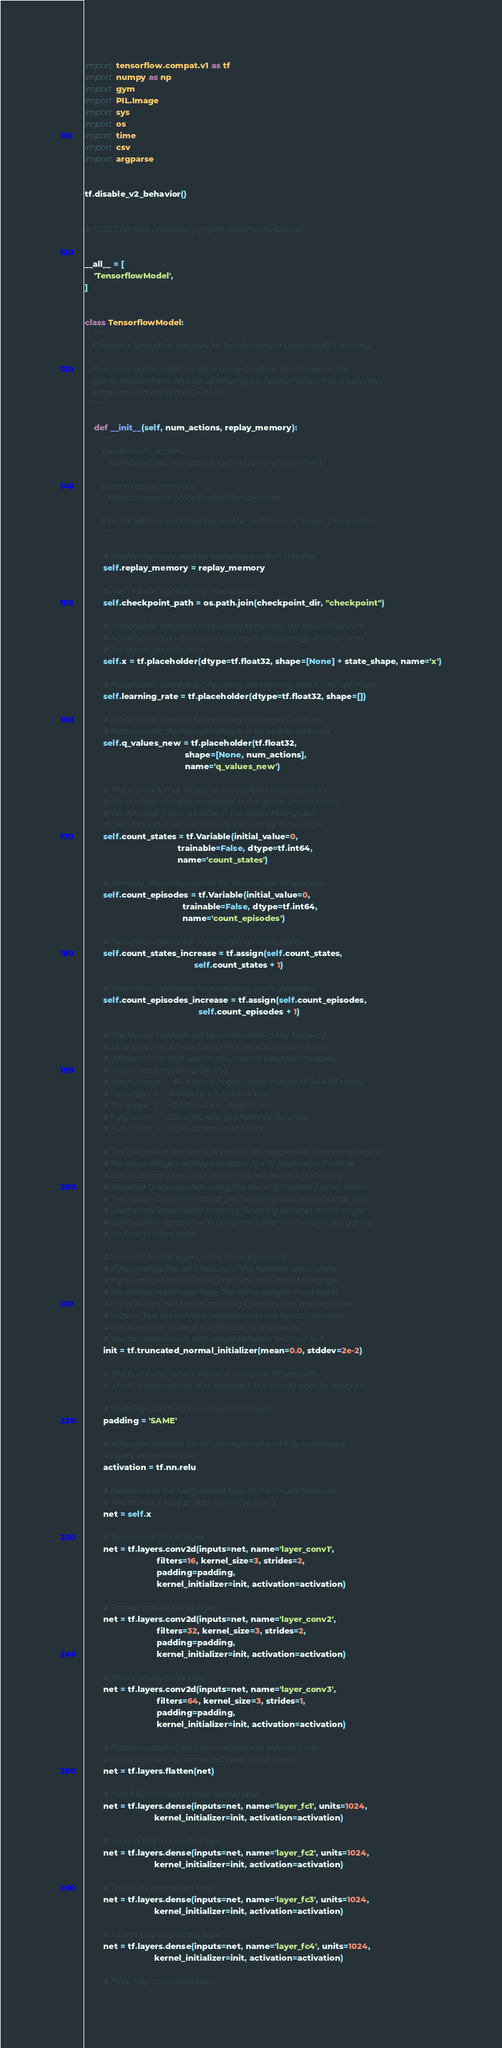<code> <loc_0><loc_0><loc_500><loc_500><_Python_>import tensorflow.compat.v1 as tf
import numpy as np
import gym
import PIL.Image
import sys
import os
import time
import csv
import argparse


tf.disable_v2_behavior()


# TODO: remove unecessary import statements (above).


__all__ = [
	'TensorflowModel',
]


class TensorflowModel:
	"""
	Creates a Tensorflow Network for Reinforcement Learning (Q-Learning).

	Functions are provided for estimating Q-values from states of the
	game-environment, and for optimizing the Neural Network so it becomes
	better at estimating the Q-values.
	"""

	def __init__(self, num_actions, replay_memory):
		"""
		:param num_actions:
			Number of discrete actions for the game-environment.

		:param replay_memory:
			Object-instance of the ReplayMemory-class.

		# HIGH: add network type parameter with choices: 'nupic' | 'tensorflow'
		"""

		# Replay-memory used for sampling random batches.
		self.replay_memory = replay_memory

		# Path for saving/restoring checkpoints.
		self.checkpoint_path = os.path.join(checkpoint_dir, "checkpoint")

		# Placeholder variable for inputting states into the Neural Network.
		# A state is a multi-dimensional array holding image-frames from
		# the game-environment.
		self.x = tf.placeholder(dtype=tf.float32, shape=[None] + state_shape, name='x')

		# Placeholder variable for inputting the learning-rate to the optimizer.
		self.learning_rate = tf.placeholder(dtype=tf.float32, shape=[])

		# Placeholder variable for inputting the target Q-values
		# that we want the Neural Network to be able to estimate.
		self.q_values_new = tf.placeholder(tf.float32,
										   shape=[None, num_actions],
										   name='q_values_new')

		# This is a hack that allows us to save/load the counter for
		# the number of states processed in the game-environment.
		# We will keep it as a variable in the TensorFlow-graph
		# even though it will not actually be used by TensorFlow.
		self.count_states = tf.Variable(initial_value=0,
										trainable=False, dtype=tf.int64,
										name='count_states')

		# Similarly, this is the counter for the number of episodes.
		self.count_episodes = tf.Variable(initial_value=0,
										  trainable=False, dtype=tf.int64,
										  name='count_episodes')

		# TensorFlow operation for increasing count_states.
		self.count_states_increase = tf.assign(self.count_states,
											   self.count_states + 1)

		# TensorFlow operation for increasing count_episodes.
		self.count_episodes_increase = tf.assign(self.count_episodes,
												 self.count_episodes + 1)

		# The Neural Network will be constructed in the following.
		# Note that the architecture of this Neural Network is very
		# different from that used in the original DeepMind papers,
		# which was something like this:
		# Input image:      84 x 84 x 4 (4 gray-scale images of 84 x 84 pixels).
		# Conv layer 1:     16 filters 8 x 8, stride 4, relu.
		# Conv layer 2:     32 filters 4 x 4, stride 2, relu.
		# Fully-conn. 1:    256 units, relu. (Sometimes 512 units).
		# Fully-conn. 2:    num-action units, linear.

		# The DeepMind architecture does a very aggressive downsampling of
		# the input images so they are about 10 x 10 pixels after the final
		# convolutional layer. I found that this resulted in significantly
		# distorted Q-values when using the training method further below.
		# The reason DeepMind could get it working was perhaps that they
		# used a very large replay memory (5x as big as here), and a single
		# optimization iteration was performed after each step of the game,
		# and some more tricks.

		# Initializer for the layers in the Neural Network.
		# If you change the architecture of the network, particularly
		# if you add or remove layers, then you may have to change
		# the stddev-parameter here. The initial weights must result
		# in the Neural Network outputting Q-values that are very close
		# to zero - but the network weights must not be too low either
		# because it will make it hard to train the network.
		# You can experiment with values between 1e-2 and 1e-3.
		init = tf.truncated_normal_initializer(mean=0.0, stddev=2e-2)

		# This builds the Neural Network using the tf.layers API,
		# which is very verbose and inelegant, but should work for everyone.

		# Padding used for the convolutional layers.
		padding = 'SAME'

		# Activation function for all convolutional and fully-connected
		# layers, except the last.
		activation = tf.nn.relu

		# Reference to the lastly added layer of the Neural Network.
		# This makes it easy to add or remove layers.
		net = self.x

		# First convolutional layer.
		net = tf.layers.conv2d(inputs=net, name='layer_conv1',
							   filters=16, kernel_size=3, strides=2,
							   padding=padding,
							   kernel_initializer=init, activation=activation)

		# Second convolutional layer.
		net = tf.layers.conv2d(inputs=net, name='layer_conv2',
							   filters=32, kernel_size=3, strides=2,
							   padding=padding,
							   kernel_initializer=init, activation=activation)

		# Third convolutional layer.
		net = tf.layers.conv2d(inputs=net, name='layer_conv3',
							   filters=64, kernel_size=3, strides=1,
							   padding=padding,
							   kernel_initializer=init, activation=activation)

		# Flatten output of the last convolutional layer so it can
		# be input to a fully-connected (aka. dense) layer.
		net = tf.layers.flatten(net)

		# First fully-connected (aka. dense) layer.
		net = tf.layers.dense(inputs=net, name='layer_fc1', units=1024,
							  kernel_initializer=init, activation=activation)

		# Second fully-connected layer.
		net = tf.layers.dense(inputs=net, name='layer_fc2', units=1024,
							  kernel_initializer=init, activation=activation)

		# Third fully-connected layer.
		net = tf.layers.dense(inputs=net, name='layer_fc3', units=1024,
							  kernel_initializer=init, activation=activation)

		# Fourth fully-connected layer.
		net = tf.layers.dense(inputs=net, name='layer_fc4', units=1024,
							  kernel_initializer=init, activation=activation)

		# Final fully-connected layer.</code> 